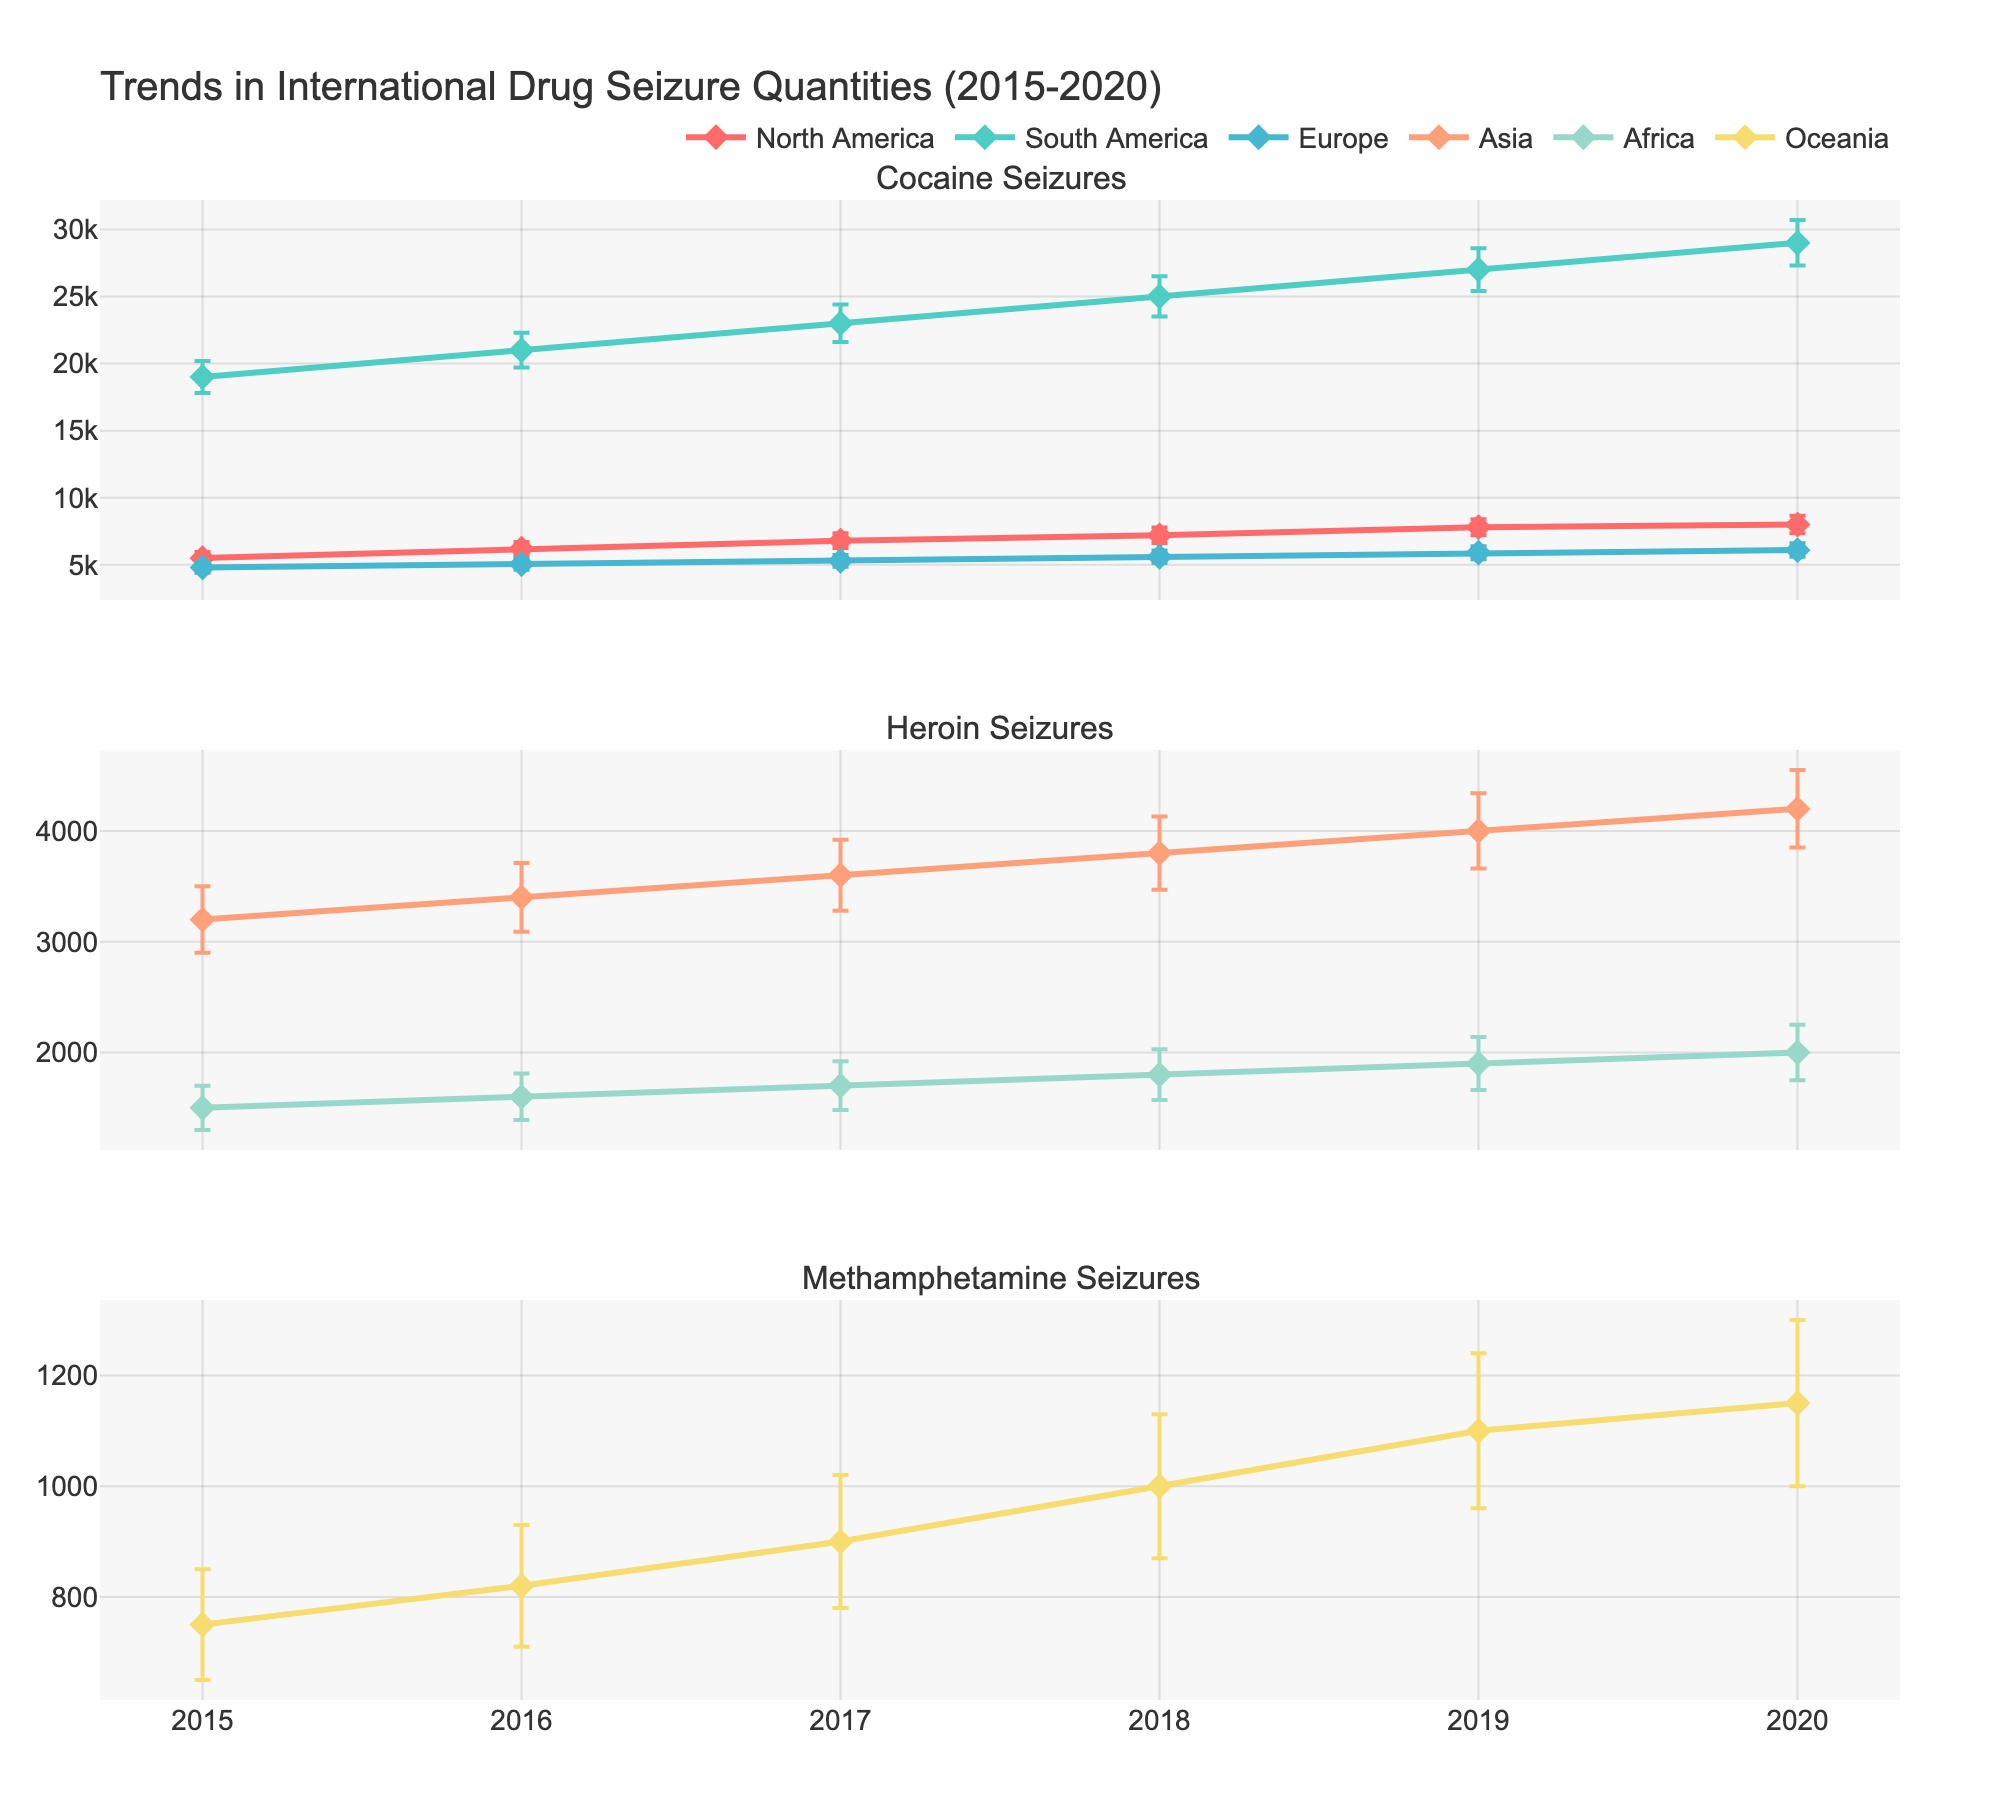What is the title of the figure? The title is usually at the top of the figure. For this one, it's "Trends in International Drug Seizure Quantities (2015-2020)."
Answer: Trends in International Drug Seizure Quantities (2015-2020) Which region had the highest mean seizure quantity of cocaine in 2018? Examine the colored lines in the Cocaine chart for the year 2018. The red line (South America) is the highest for that year.
Answer: South America How much did the mean heroin seizure quantity increase in Asia from 2015 to 2020? Look at the heroin chart and compare the 2015 and 2020 data points for Asia. 4200 kg in 2020 minus 3200 kg in 2015.
Answer: 1000 kg Which drug showed an increasing trend in mean seizure quantity in North America from 2015 to 2020? Follow the North America line across years in each subplot. The Cocaine line in North America increases over the years.
Answer: Cocaine Compare the standard deviation of methamphetamine seizures in Oceania in 2020 with 2018. Did it increase or decrease? Check the error bars for Oceania in the Methamphetamine line in 2020 and 2018. The error bar length increased from 130 kg in 2018 to 150 kg in 2020.
Answer: Increase In 2017, which region seized more heroin: Asia or Africa? Look at the Heroin chart for 2017 and compare the corresponding points for Asia and Africa. Asia's mean value is higher.
Answer: Asia What is the general trend for methamphetamine seizures in Oceania from 2015 to 2020? Track the line across years in the Oceania region in the Methamphetamine chart. The trend is generally increasing.
Answer: Increasing What can be said about the variability of cocaine seizure quantities in South America compared to North America in 2019? Compare the length of the error bars (standard deviation) for South America and North America in the Cocaine chart for the year 2019. South America's error bar is longer.
Answer: South America has higher variability Which region showed the smallest change in mean heroin seizures from 2015 to 2020? Compare the dosages for all regions across the years in the Heroin chart. Africa shows a smaller change compared to the others.
Answer: Africa By how much did the mean seizure quantity of cocaine in South America increase from 2015 to 2020? Check the Cocaine chart for South America's mean values for 2015 and 2020, then calculate the difference (29000 kg - 19000 kg).
Answer: 10000 kg 